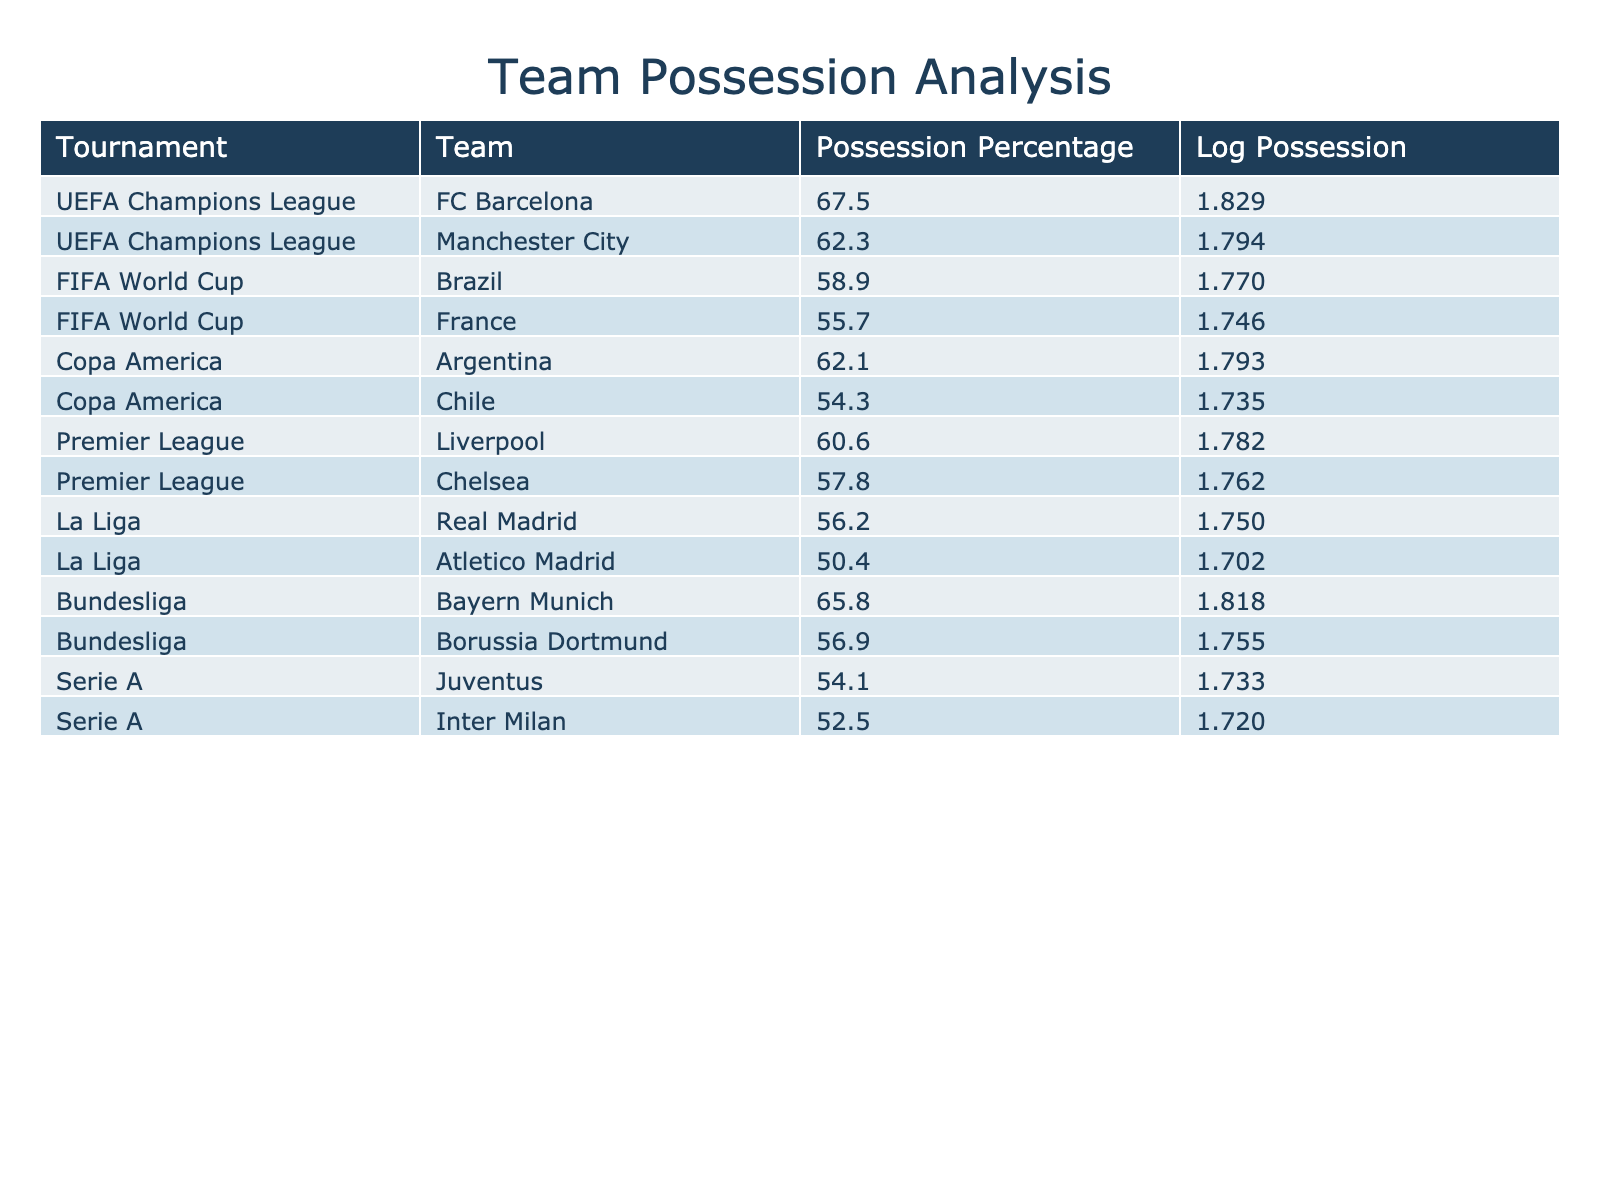What is the possession percentage of FC Barcelona in the UEFA Champions League? The table shows that FC Barcelona has a possession percentage of 67.5% in the UEFA Champions League.
Answer: 67.5% Which team has the lowest possession percentage in the table? By examining the possession percentages in the table, Atletico Madrid has the lowest possession percentage at 50.4%.
Answer: 50.4% What is the average possession percentage for teams in the FIFA World Cup? The possession percentages for Brazil and France in the FIFA World Cup are 58.9% and 55.7%, respectively. The average is (58.9 + 55.7) / 2 = 57.3%.
Answer: 57.3% Is it true that Bayern Munich had a higher possession percentage than Liverpool? Bayern Munich has a possession percentage of 65.8%, while Liverpool has 60.6%. Since 65.8% is greater than 60.6%, the statement is true.
Answer: Yes What is the difference in possession percentage between the highest and lowest values in La Liga? In La Liga, Real Madrid has a possession percentage of 56.2% and Atletico Madrid has 50.4%. The difference is 56.2 - 50.4 = 5.8%.
Answer: 5.8% Which tournament has the highest average possession percentage and what is that value? The UEFA Champions League teams have possession percentages of 67.5% and 62.3%, averaging (67.5 + 62.3) / 2 = 64.9%. Other tournaments have lower averages, so the UEFA Champions League has the highest average of 64.9%.
Answer: 64.9% How many teams in the Bundesliga have possession percentages greater than 60%? In the table, Bayern Munich (65.8%) is the only team with a possession percentage greater than 60% in the Bundesliga, while Borussia Dortmund has 56.9%. Therefore, there is one team with such a percentage.
Answer: 1 What is the log possession value of Juventus? The possession percentage for Juventus is 54.1%. The logarithmic value can be calculated as log10(54.1) ≈ 1.733, which can be verified using a calculator.
Answer: 1.733 